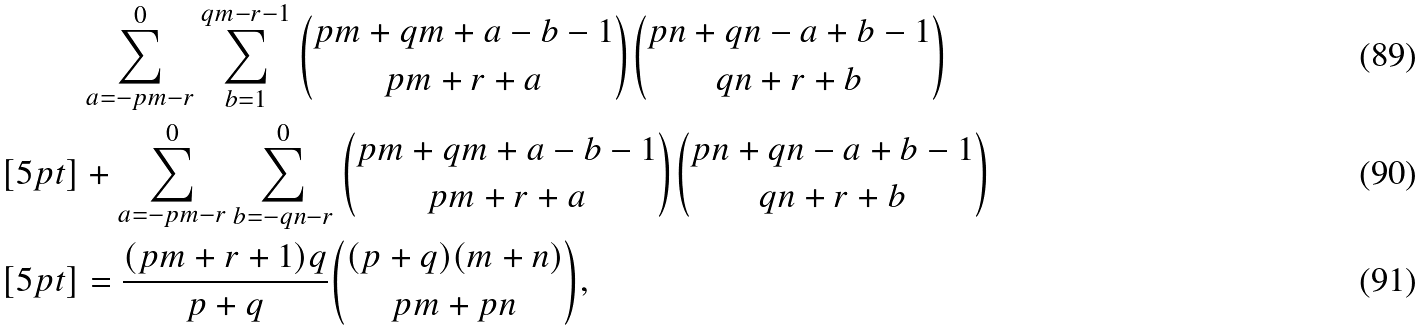<formula> <loc_0><loc_0><loc_500><loc_500>& \sum _ { a = - p m - r } ^ { 0 } \sum _ { b = 1 } ^ { q m - r - 1 } { p m + q m + a - b - 1 \choose p m + r + a } { p n + q n - a + b - 1 \choose q n + r + b } \\ [ 5 p t ] & + \sum _ { a = - p m - r } ^ { 0 } \sum _ { b = - q n - r } ^ { 0 } { p m + q m + a - b - 1 \choose p m + r + a } { p n + q n - a + b - 1 \choose q n + r + b } \\ [ 5 p t ] & = \frac { ( p m + r + 1 ) q } { p + q } { ( p + q ) ( m + n ) \choose p m + p n } ,</formula> 